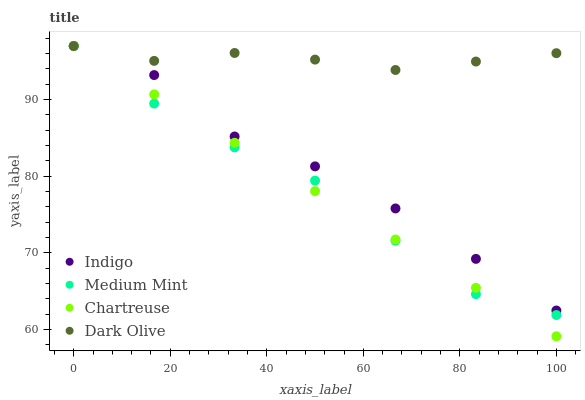Does Medium Mint have the minimum area under the curve?
Answer yes or no. Yes. Does Dark Olive have the maximum area under the curve?
Answer yes or no. Yes. Does Chartreuse have the minimum area under the curve?
Answer yes or no. No. Does Chartreuse have the maximum area under the curve?
Answer yes or no. No. Is Chartreuse the smoothest?
Answer yes or no. Yes. Is Medium Mint the roughest?
Answer yes or no. Yes. Is Dark Olive the smoothest?
Answer yes or no. No. Is Dark Olive the roughest?
Answer yes or no. No. Does Chartreuse have the lowest value?
Answer yes or no. Yes. Does Dark Olive have the lowest value?
Answer yes or no. No. Does Indigo have the highest value?
Answer yes or no. Yes. Does Dark Olive intersect Medium Mint?
Answer yes or no. Yes. Is Dark Olive less than Medium Mint?
Answer yes or no. No. Is Dark Olive greater than Medium Mint?
Answer yes or no. No. 